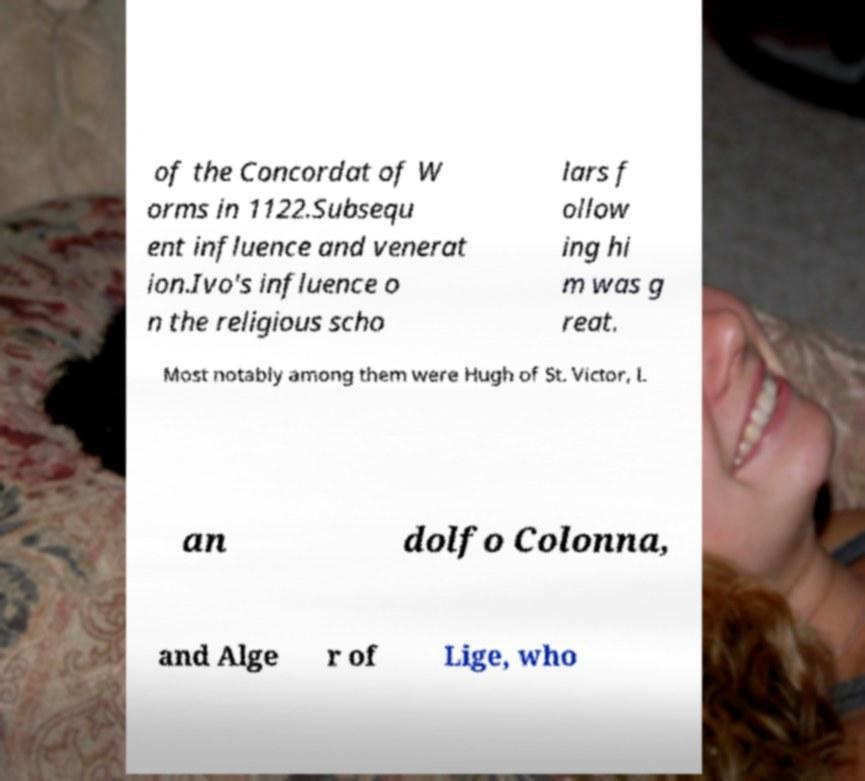I need the written content from this picture converted into text. Can you do that? of the Concordat of W orms in 1122.Subsequ ent influence and venerat ion.Ivo's influence o n the religious scho lars f ollow ing hi m was g reat. Most notably among them were Hugh of St. Victor, L an dolfo Colonna, and Alge r of Lige, who 